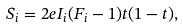<formula> <loc_0><loc_0><loc_500><loc_500>S _ { i } = 2 e I _ { i } ( F _ { i } - 1 ) t ( 1 - t ) ,</formula> 